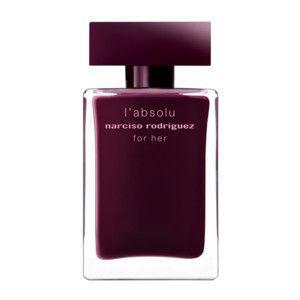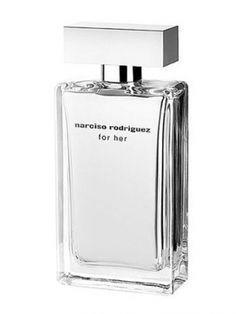The first image is the image on the left, the second image is the image on the right. Assess this claim about the two images: "The image on the right contains both a bottle and a box.". Correct or not? Answer yes or no. No. 